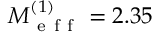<formula> <loc_0><loc_0><loc_500><loc_500>M _ { e f f } ^ { ( 1 ) } = 2 . 3 5</formula> 